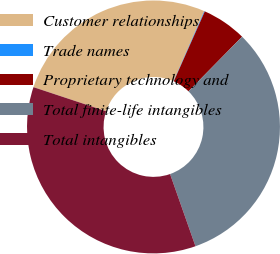<chart> <loc_0><loc_0><loc_500><loc_500><pie_chart><fcel>Customer relationships<fcel>Trade names<fcel>Proprietary technology and<fcel>Total finite-life intangibles<fcel>Total intangibles<nl><fcel>26.48%<fcel>0.08%<fcel>5.7%<fcel>32.26%<fcel>35.48%<nl></chart> 